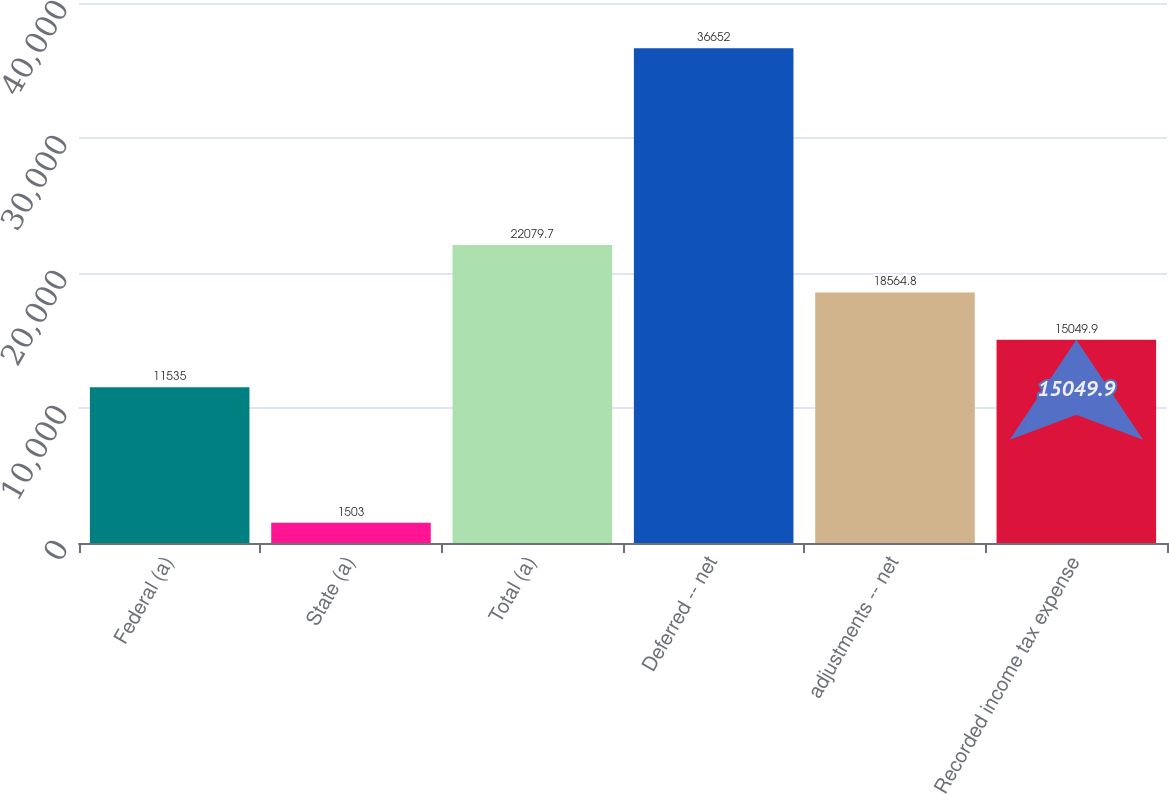Convert chart to OTSL. <chart><loc_0><loc_0><loc_500><loc_500><bar_chart><fcel>Federal (a)<fcel>State (a)<fcel>Total (a)<fcel>Deferred -- net<fcel>adjustments -- net<fcel>Recorded income tax expense<nl><fcel>11535<fcel>1503<fcel>22079.7<fcel>36652<fcel>18564.8<fcel>15049.9<nl></chart> 